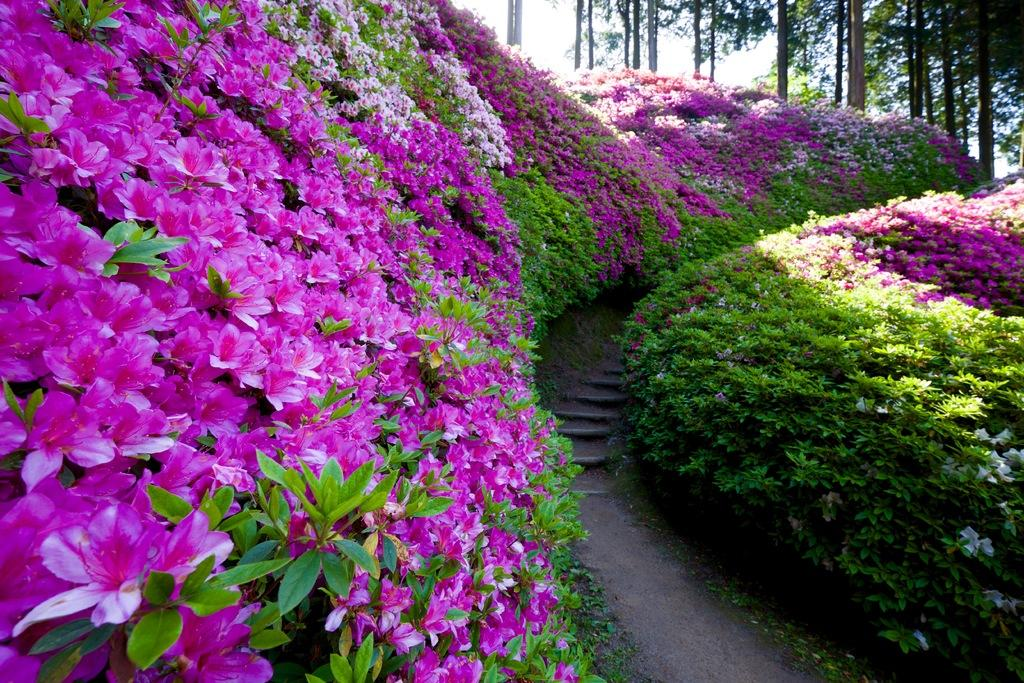What type of vegetation can be seen in the image? There are flowers, plants, and trees visible in the image. What part of the natural environment is visible in the image? The sky is visible in the image. Can you describe the background of the image? The background of the image includes trees. Where is the robin sitting in the image? There is no robin present in the image. What type of seat can be seen in the image? There is no seat present in the image. 